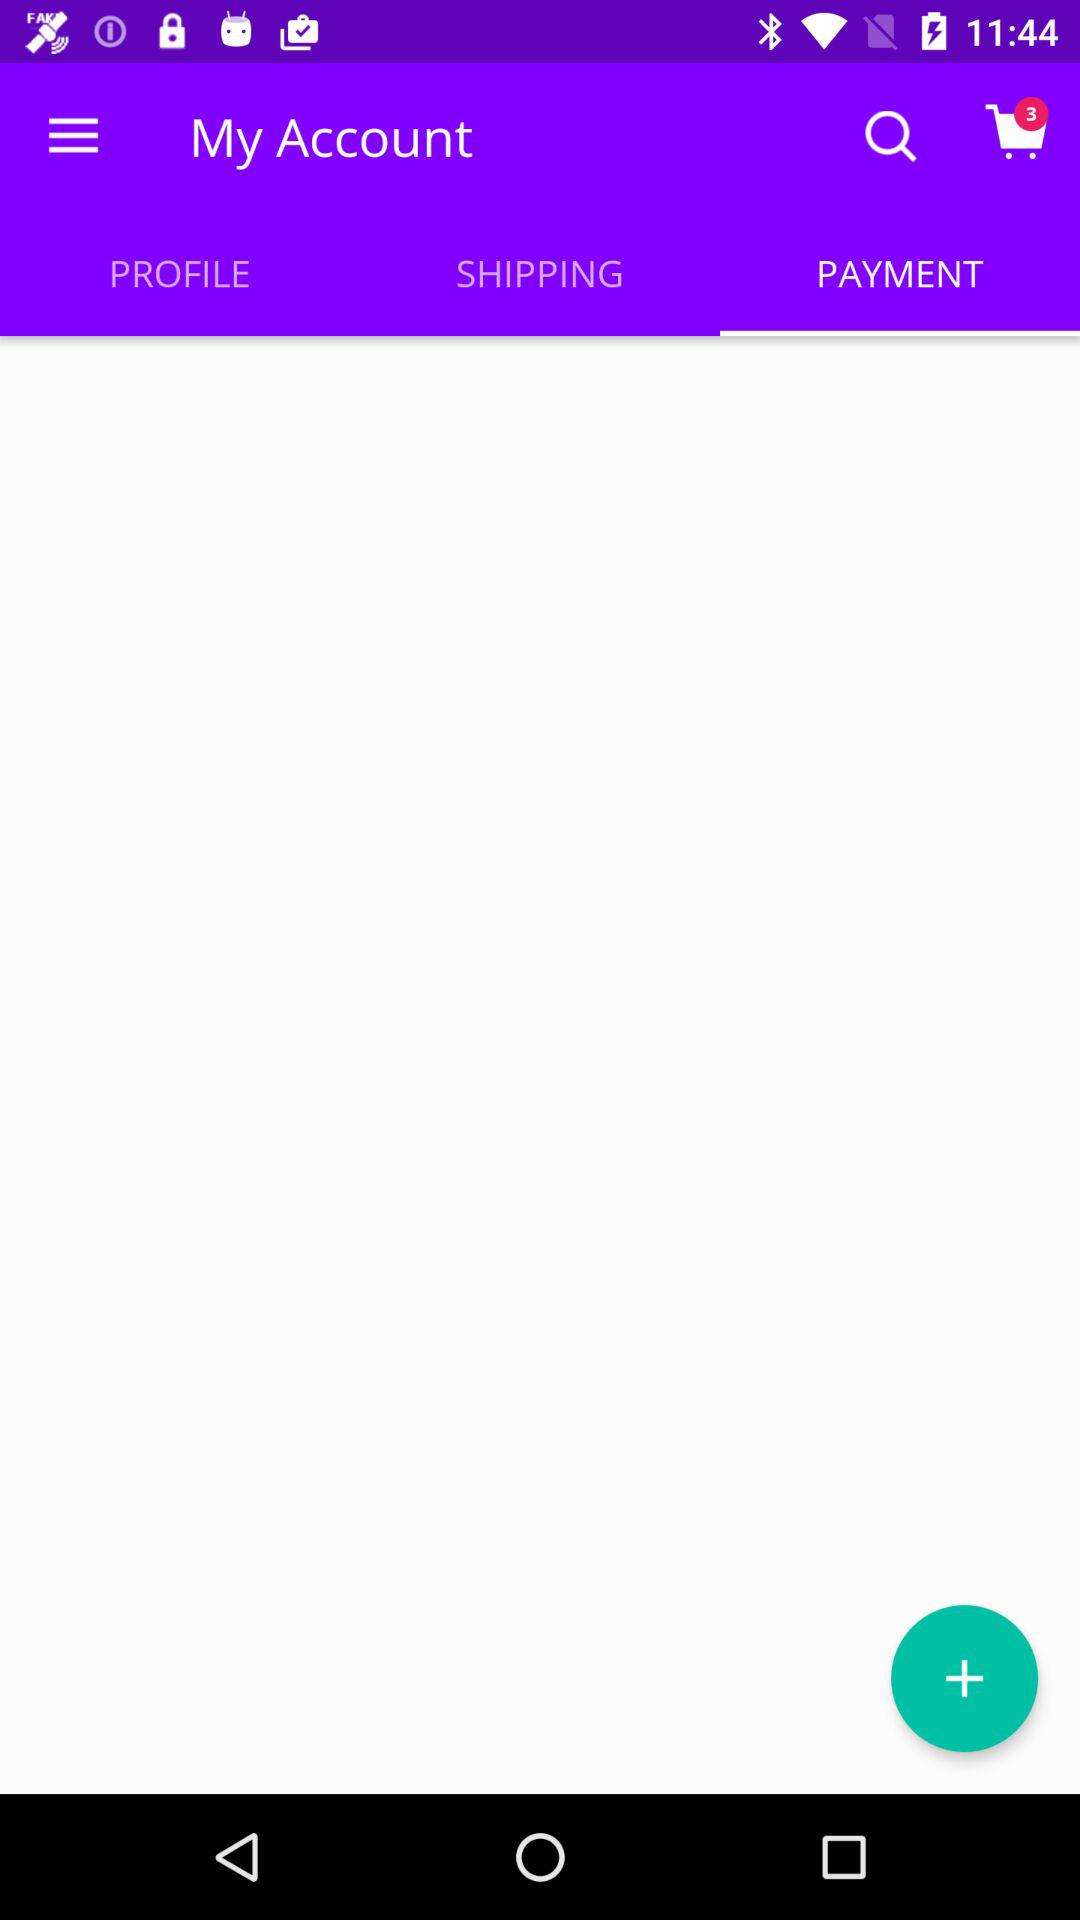How many items are in the shopping cart if I add one more?
Answer the question using a single word or phrase. 4 